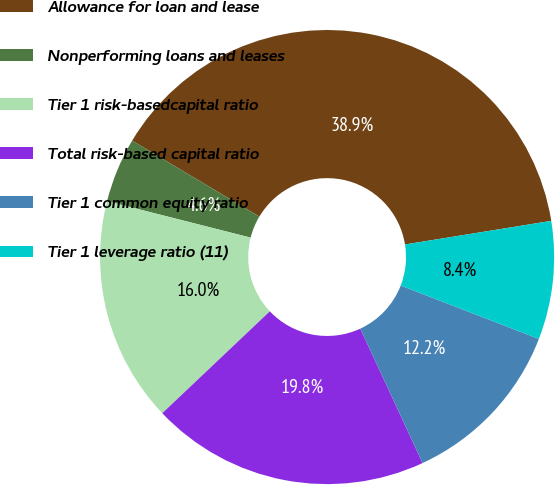<chart> <loc_0><loc_0><loc_500><loc_500><pie_chart><fcel>Allowance for loan and lease<fcel>Nonperforming loans and leases<fcel>Tier 1 risk-basedcapital ratio<fcel>Total risk-based capital ratio<fcel>Tier 1 common equity ratio<fcel>Tier 1 leverage ratio (11)<nl><fcel>38.89%<fcel>4.61%<fcel>16.03%<fcel>19.84%<fcel>12.22%<fcel>8.42%<nl></chart> 